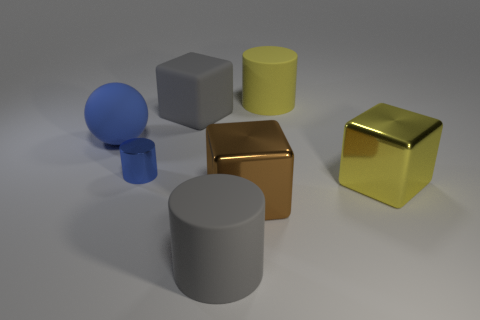What number of gray things are behind the big metal cube that is left of the large cylinder on the right side of the gray cylinder?
Offer a very short reply. 1. How many rubber objects are yellow objects or big brown blocks?
Offer a very short reply. 1. What is the color of the cylinder that is to the right of the small blue thing and in front of the sphere?
Your answer should be very brief. Gray. Do the cylinder that is in front of the blue shiny object and the tiny shiny cylinder have the same size?
Your response must be concise. No. How many objects are either gray things that are in front of the large blue object or spheres?
Offer a terse response. 2. Are there any brown cubes that have the same size as the yellow metal thing?
Provide a short and direct response. Yes. There is a yellow object that is the same size as the yellow cube; what is it made of?
Your response must be concise. Rubber. There is a metallic object that is in front of the tiny blue thing and on the left side of the big yellow cylinder; what is its shape?
Your answer should be compact. Cube. The big matte object right of the big gray rubber cylinder is what color?
Keep it short and to the point. Yellow. How big is the thing that is to the left of the big matte cube and behind the small blue metallic cylinder?
Your answer should be compact. Large. 